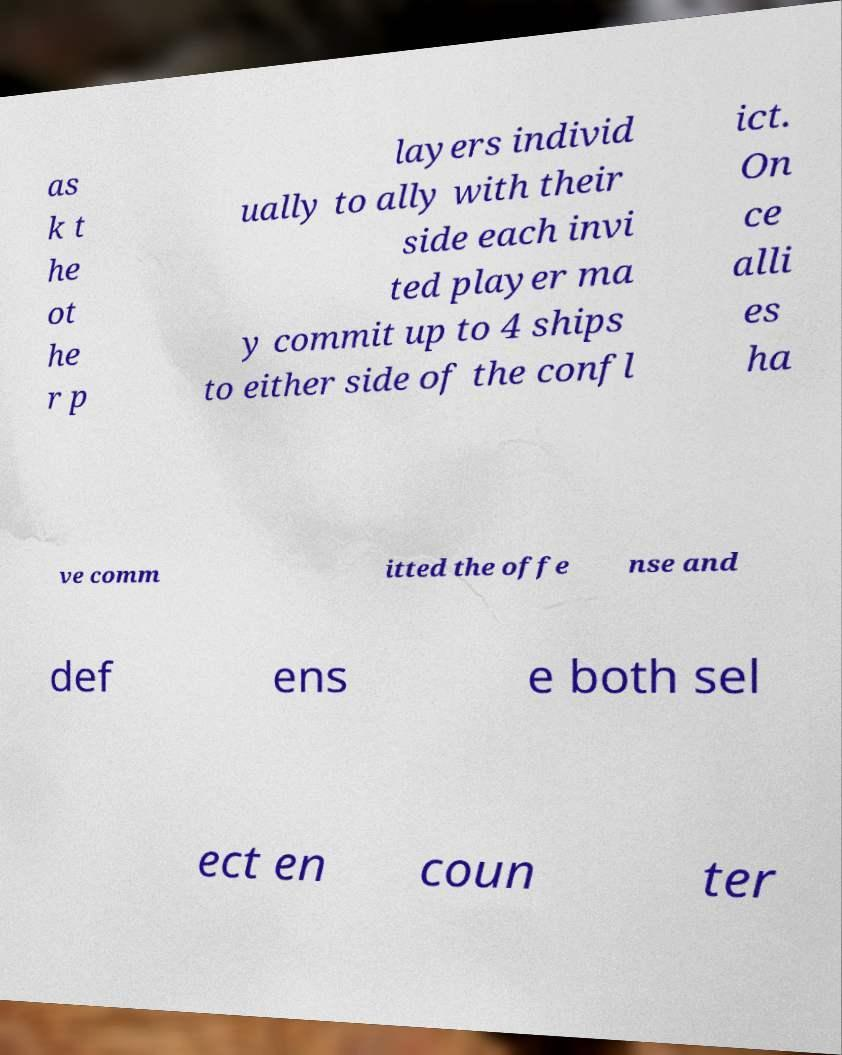There's text embedded in this image that I need extracted. Can you transcribe it verbatim? as k t he ot he r p layers individ ually to ally with their side each invi ted player ma y commit up to 4 ships to either side of the confl ict. On ce alli es ha ve comm itted the offe nse and def ens e both sel ect en coun ter 